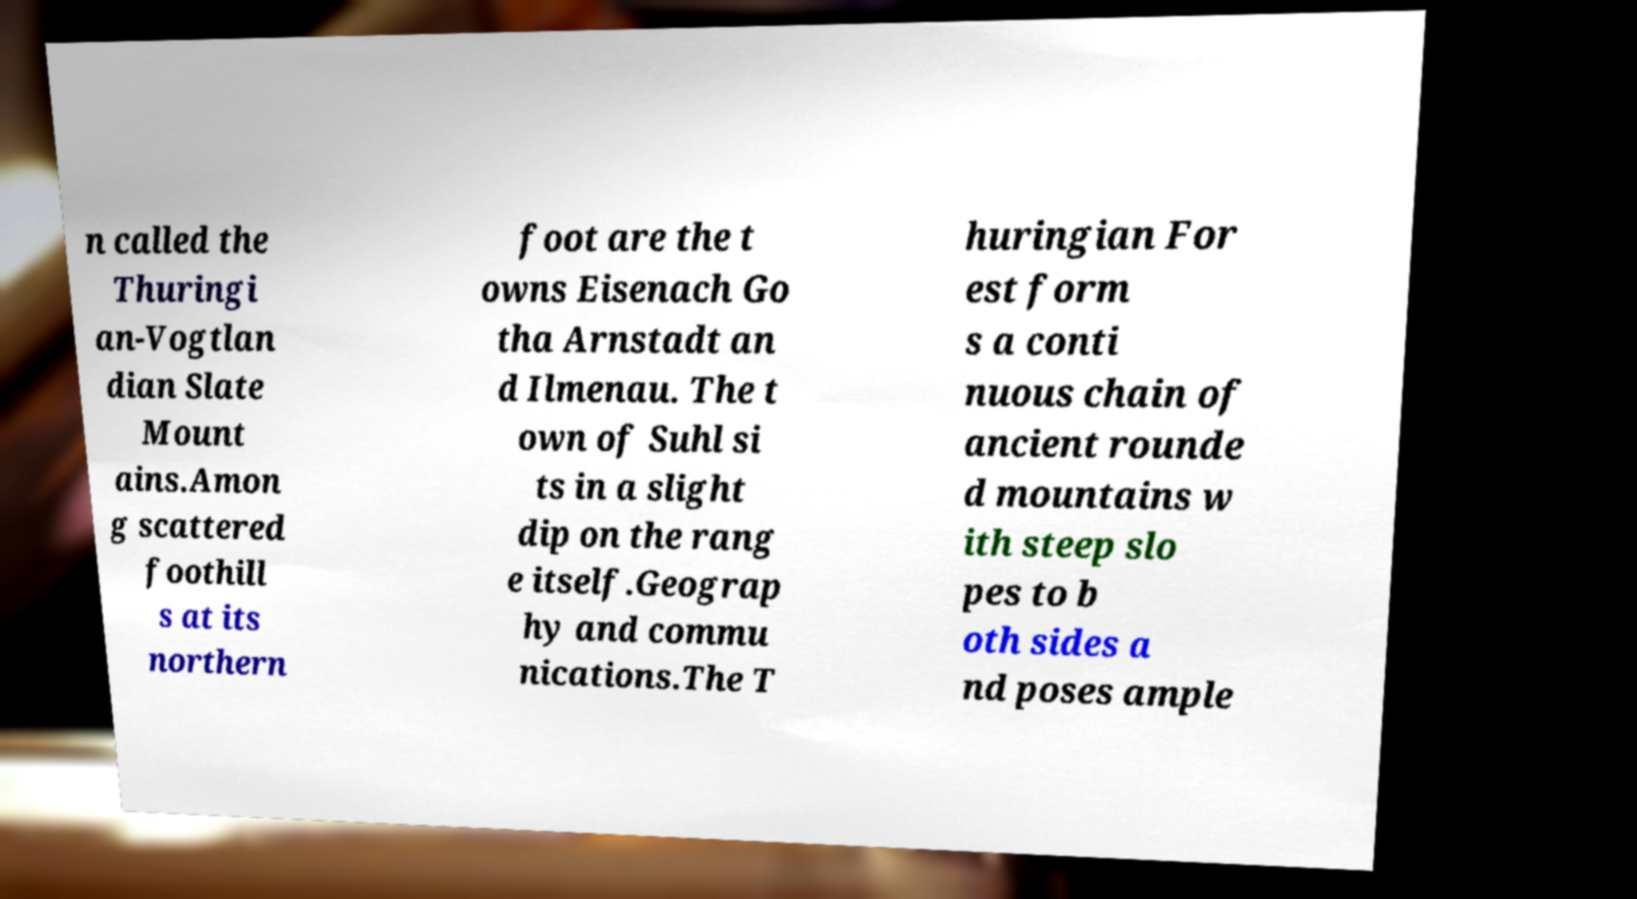Could you extract and type out the text from this image? n called the Thuringi an-Vogtlan dian Slate Mount ains.Amon g scattered foothill s at its northern foot are the t owns Eisenach Go tha Arnstadt an d Ilmenau. The t own of Suhl si ts in a slight dip on the rang e itself.Geograp hy and commu nications.The T huringian For est form s a conti nuous chain of ancient rounde d mountains w ith steep slo pes to b oth sides a nd poses ample 